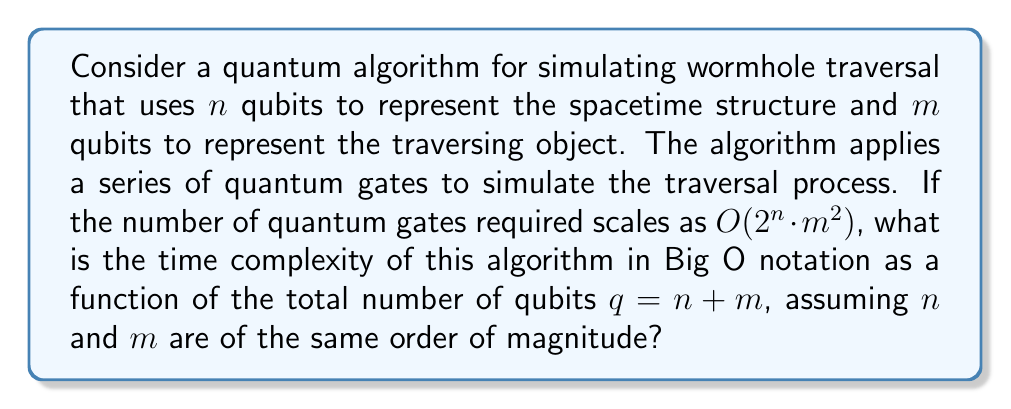Show me your answer to this math problem. To analyze the time complexity of this quantum algorithm, we need to express it in terms of the total number of qubits $q$. Let's approach this step-by-step:

1) We're given that the number of quantum gates scales as $O(2^n \cdot m^2)$.

2) We know that $q = n + m$, and $n$ and $m$ are of the same order of magnitude. This means we can express $n$ and $m$ in terms of $q$:

   $n \approx m \approx \frac{q}{2}$

3) Substituting these into our original expression:

   $O(2^n \cdot m^2) \approx O(2^{q/2} \cdot (q/2)^2)$

4) Simplify:

   $O(2^{q/2} \cdot q^2/4)$

5) The constant factor 1/4 can be dropped in Big O notation:

   $O(2^{q/2} \cdot q^2)$

6) Note that $q^2$ grows much slower than $2^{q/2}$, so it becomes negligible for large $q$. Therefore, we can further simplify:

   $O(2^{q/2})$

This is our final time complexity in terms of the total number of qubits $q$.
Answer: $O(2^{q/2})$ 